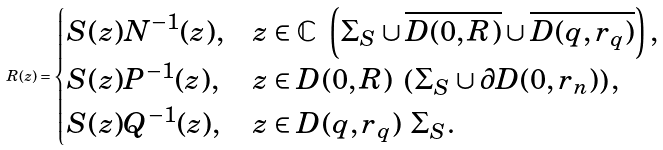Convert formula to latex. <formula><loc_0><loc_0><loc_500><loc_500>R ( z ) = \begin{cases} S ( z ) N ^ { - 1 } ( z ) , & z \in \mathbb { C } \ \left ( \Sigma _ { S } \cup \overline { D ( 0 , R ) } \cup \overline { D ( q , r _ { q } ) } \right ) , \\ S ( z ) P ^ { - 1 } ( z ) , & z \in D ( 0 , R ) \ \left ( \Sigma _ { S } \cup \partial D ( 0 , r _ { n } ) \right ) , \\ S ( z ) Q ^ { - 1 } ( z ) , & z \in D ( q , r _ { q } ) \ \Sigma _ { S } . \end{cases}</formula> 